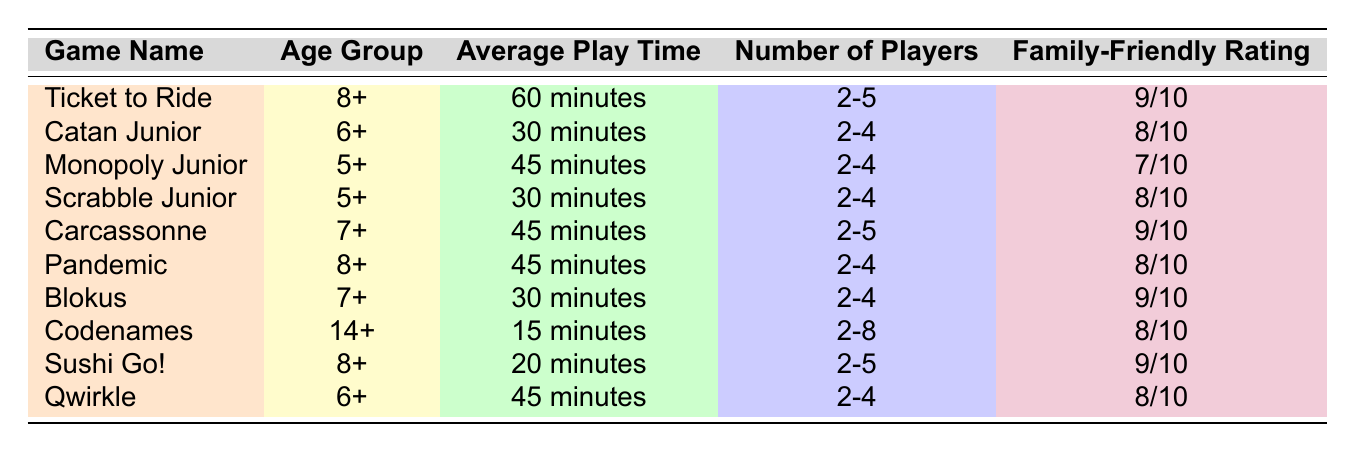What is the average play time for "Catan Junior"? The average play time for "Catan Junior" is listed in the table as 30 minutes.
Answer: 30 minutes How many players can "Pandemic" accommodate? According to the table, "Pandemic" can accommodate between 2 to 4 players.
Answer: 2-4 players Is "Monopoly Junior" rated higher than 7/10? The family-friendly rating for "Monopoly Junior" is 7/10, which means it is not rated higher than that.
Answer: No Which game has the longest average play time? By examining the average play times in the table, "Ticket to Ride" has the longest average play time at 60 minutes.
Answer: 60 minutes How many games are designed for ages 8 and up? The table shows three games designed for ages 8 and up: "Ticket to Ride", "Pandemic", and "Sushi Go!". Therefore, the total is 3 games.
Answer: 3 games What is the average family-friendly rating of games rated 8/10? The table lists three games rated 8/10: "Catan Junior", "Pandemic", and "Qwirkle". Adding these ratings gives (8 + 8 + 8) = 24. Dividing by the number of games (3) gives an average of 24/3 = 8.
Answer: 8 Is "Codenames" suitable for children under 14? The table specifies that "Codenames" is marked for ages 14+, making it unsuitable for children under that age.
Answer: No Which game has the lowest family-friendly rating, and what is that rating? The lowest family-friendly rating shown in the table belongs to "Monopoly Junior", which has a rating of 7/10.
Answer: Monopoly Junior, 7/10 What is the total number of players that can be accommodated by all games rated 9/10? The games rated 9/10 are "Ticket to Ride", "Carcassonne", "Blokus", and "Sushi Go!". Their player numbers are 2-5, 2-5, 2-4, and 2-5 respectively. Therefore, the maximum total is (5 + 5 + 4 + 5) = 19 players across these games.
Answer: 19 players 